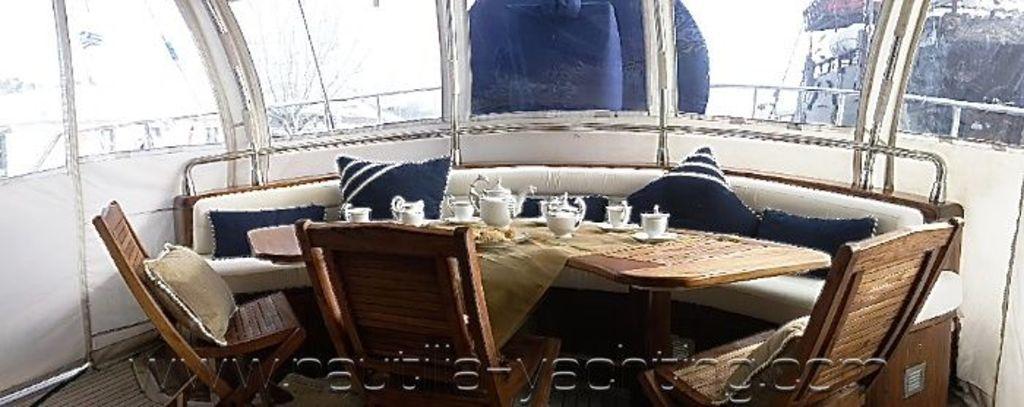Can you describe this image briefly? In this image we can see inside view of a room. In the center of the image we can see a group of cups on causes, a jug kept on the table. In the foreground we can see some chairs. In the background, we can see the sofa, windows, railing, tree, a shed and the sky. 